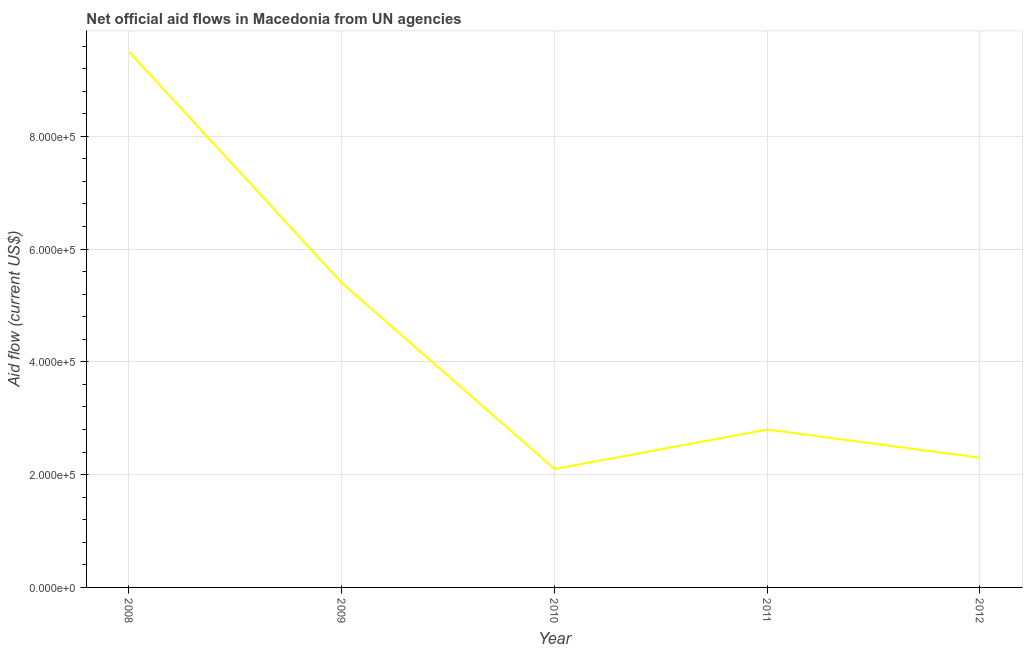What is the net official flows from un agencies in 2011?
Your answer should be compact. 2.80e+05. Across all years, what is the maximum net official flows from un agencies?
Keep it short and to the point. 9.50e+05. Across all years, what is the minimum net official flows from un agencies?
Provide a succinct answer. 2.10e+05. What is the sum of the net official flows from un agencies?
Give a very brief answer. 2.21e+06. What is the difference between the net official flows from un agencies in 2008 and 2009?
Offer a terse response. 4.10e+05. What is the average net official flows from un agencies per year?
Your response must be concise. 4.42e+05. What is the median net official flows from un agencies?
Your response must be concise. 2.80e+05. In how many years, is the net official flows from un agencies greater than 600000 US$?
Offer a terse response. 1. What is the ratio of the net official flows from un agencies in 2010 to that in 2012?
Ensure brevity in your answer.  0.91. Is the net official flows from un agencies in 2010 less than that in 2012?
Your response must be concise. Yes. What is the difference between the highest and the second highest net official flows from un agencies?
Your response must be concise. 4.10e+05. What is the difference between the highest and the lowest net official flows from un agencies?
Provide a succinct answer. 7.40e+05. Does the net official flows from un agencies monotonically increase over the years?
Ensure brevity in your answer.  No. What is the difference between two consecutive major ticks on the Y-axis?
Your response must be concise. 2.00e+05. Are the values on the major ticks of Y-axis written in scientific E-notation?
Provide a short and direct response. Yes. What is the title of the graph?
Make the answer very short. Net official aid flows in Macedonia from UN agencies. What is the label or title of the X-axis?
Your answer should be very brief. Year. What is the Aid flow (current US$) in 2008?
Make the answer very short. 9.50e+05. What is the Aid flow (current US$) in 2009?
Your answer should be very brief. 5.40e+05. What is the Aid flow (current US$) of 2010?
Offer a terse response. 2.10e+05. What is the Aid flow (current US$) of 2012?
Your answer should be very brief. 2.30e+05. What is the difference between the Aid flow (current US$) in 2008 and 2009?
Make the answer very short. 4.10e+05. What is the difference between the Aid flow (current US$) in 2008 and 2010?
Ensure brevity in your answer.  7.40e+05. What is the difference between the Aid flow (current US$) in 2008 and 2011?
Your answer should be very brief. 6.70e+05. What is the difference between the Aid flow (current US$) in 2008 and 2012?
Your answer should be very brief. 7.20e+05. What is the difference between the Aid flow (current US$) in 2009 and 2010?
Ensure brevity in your answer.  3.30e+05. What is the difference between the Aid flow (current US$) in 2009 and 2011?
Offer a very short reply. 2.60e+05. What is the difference between the Aid flow (current US$) in 2010 and 2011?
Your response must be concise. -7.00e+04. What is the difference between the Aid flow (current US$) in 2010 and 2012?
Your answer should be compact. -2.00e+04. What is the difference between the Aid flow (current US$) in 2011 and 2012?
Provide a succinct answer. 5.00e+04. What is the ratio of the Aid flow (current US$) in 2008 to that in 2009?
Your answer should be very brief. 1.76. What is the ratio of the Aid flow (current US$) in 2008 to that in 2010?
Offer a very short reply. 4.52. What is the ratio of the Aid flow (current US$) in 2008 to that in 2011?
Ensure brevity in your answer.  3.39. What is the ratio of the Aid flow (current US$) in 2008 to that in 2012?
Give a very brief answer. 4.13. What is the ratio of the Aid flow (current US$) in 2009 to that in 2010?
Offer a terse response. 2.57. What is the ratio of the Aid flow (current US$) in 2009 to that in 2011?
Provide a succinct answer. 1.93. What is the ratio of the Aid flow (current US$) in 2009 to that in 2012?
Keep it short and to the point. 2.35. What is the ratio of the Aid flow (current US$) in 2011 to that in 2012?
Make the answer very short. 1.22. 